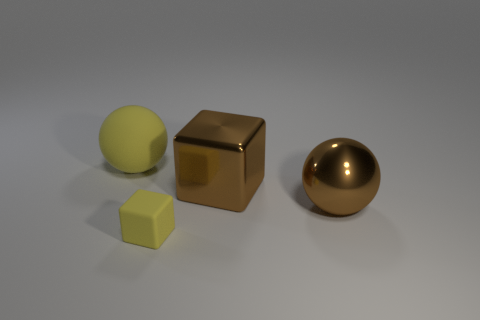Add 3 tiny yellow balls. How many objects exist? 7 Subtract all large red spheres. Subtract all metallic things. How many objects are left? 2 Add 3 brown things. How many brown things are left? 5 Add 4 matte things. How many matte things exist? 6 Subtract 0 purple cylinders. How many objects are left? 4 